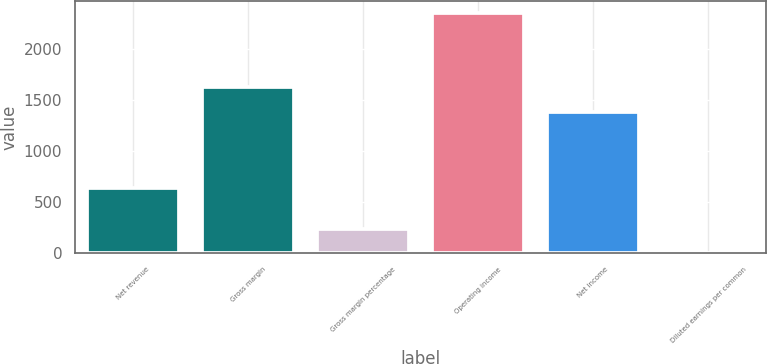Convert chart to OTSL. <chart><loc_0><loc_0><loc_500><loc_500><bar_chart><fcel>Net revenue<fcel>Gross margin<fcel>Gross margin percentage<fcel>Operating income<fcel>Net income<fcel>Diluted earnings per common<nl><fcel>633<fcel>1630<fcel>234.92<fcel>2347<fcel>1385<fcel>0.24<nl></chart> 